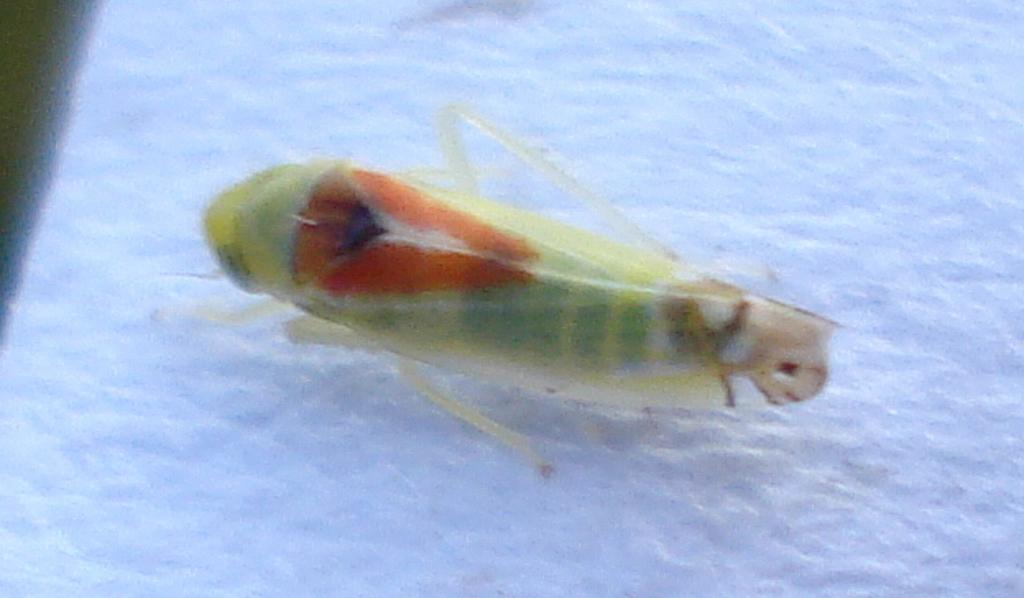What type of creature can be seen in the image? There is an insect in the image. What type of lipstick is the insect wearing in the image? There is no lipstick or any indication of cosmetics in the image, as it features an insect. 